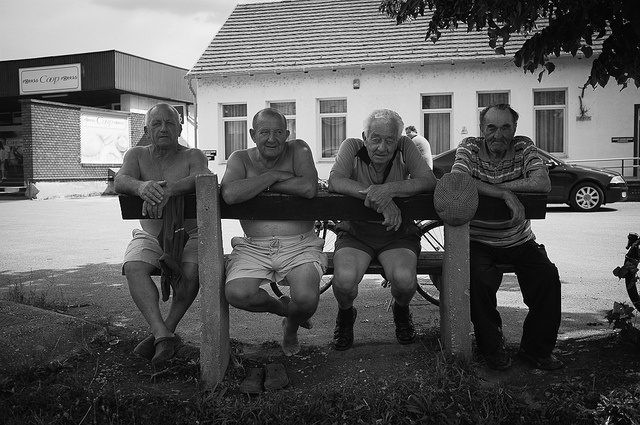Describe the objects in this image and their specific colors. I can see bench in lightgray, black, gray, and darkgray tones, people in lightgray, gray, black, and darkgray tones, people in lightgray, black, gray, and darkgray tones, people in lightgray, black, gray, and darkgray tones, and people in lightgray, gray, black, and darkgray tones in this image. 